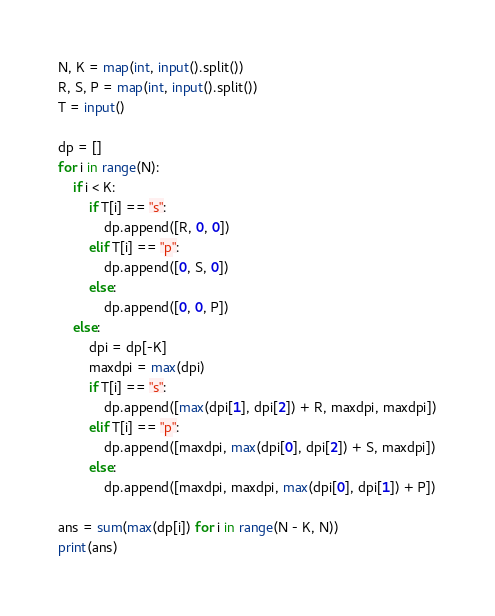<code> <loc_0><loc_0><loc_500><loc_500><_Python_>N, K = map(int, input().split())
R, S, P = map(int, input().split())
T = input()

dp = []
for i in range(N):
    if i < K:
        if T[i] == "s":
            dp.append([R, 0, 0])
        elif T[i] == "p":
            dp.append([0, S, 0])
        else:
            dp.append([0, 0, P])
    else:
        dpi = dp[-K]
        maxdpi = max(dpi)
        if T[i] == "s":
            dp.append([max(dpi[1], dpi[2]) + R, maxdpi, maxdpi])
        elif T[i] == "p":
            dp.append([maxdpi, max(dpi[0], dpi[2]) + S, maxdpi])
        else:
            dp.append([maxdpi, maxdpi, max(dpi[0], dpi[1]) + P])

ans = sum(max(dp[i]) for i in range(N - K, N))
print(ans)
</code> 